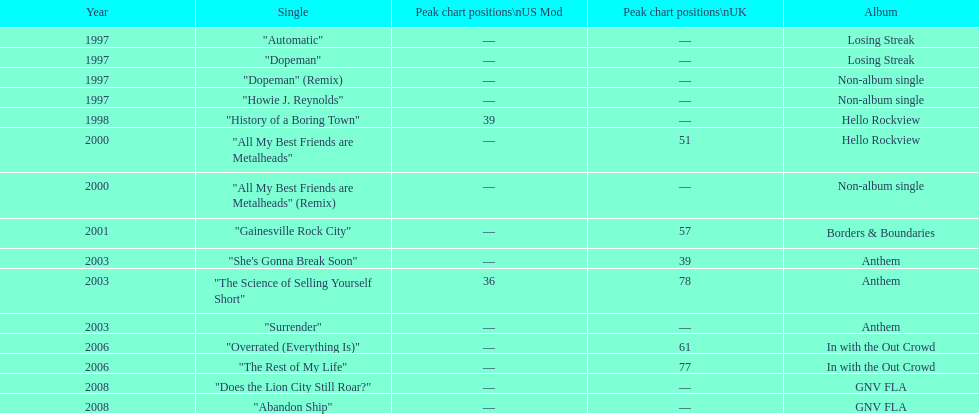From which album was the single "automatic" taken? Losing Streak. 